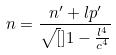<formula> <loc_0><loc_0><loc_500><loc_500>n = \frac { n ^ { \prime } + l p ^ { \prime } } { \sqrt { [ } ] { 1 - \frac { l ^ { 4 } } { c ^ { 4 } } } }</formula> 